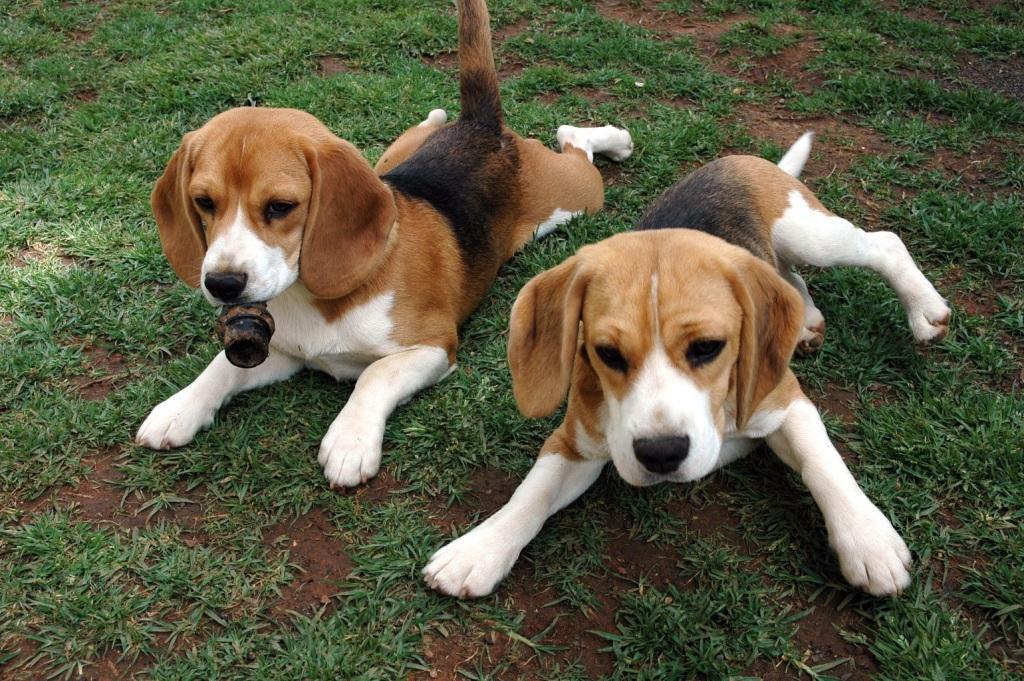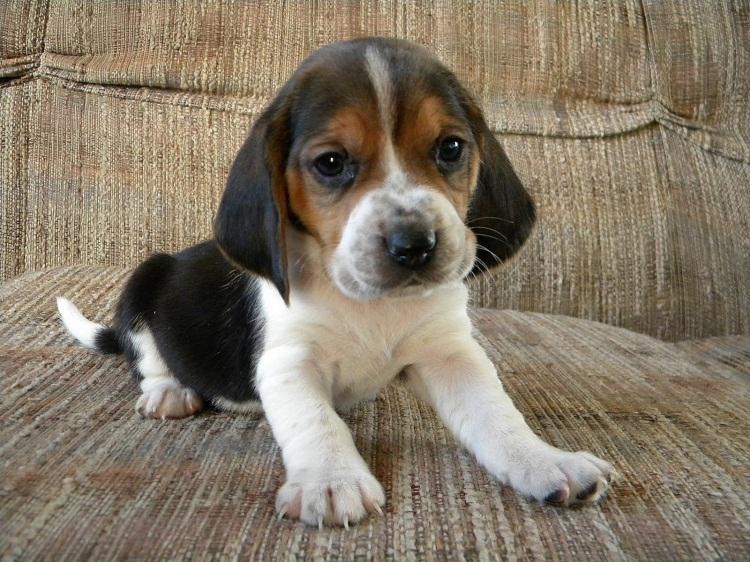The first image is the image on the left, the second image is the image on the right. Evaluate the accuracy of this statement regarding the images: "The left image contains at least two dogs.". Is it true? Answer yes or no. Yes. The first image is the image on the left, the second image is the image on the right. Given the left and right images, does the statement "There are no less than three beagle puppies" hold true? Answer yes or no. Yes. 